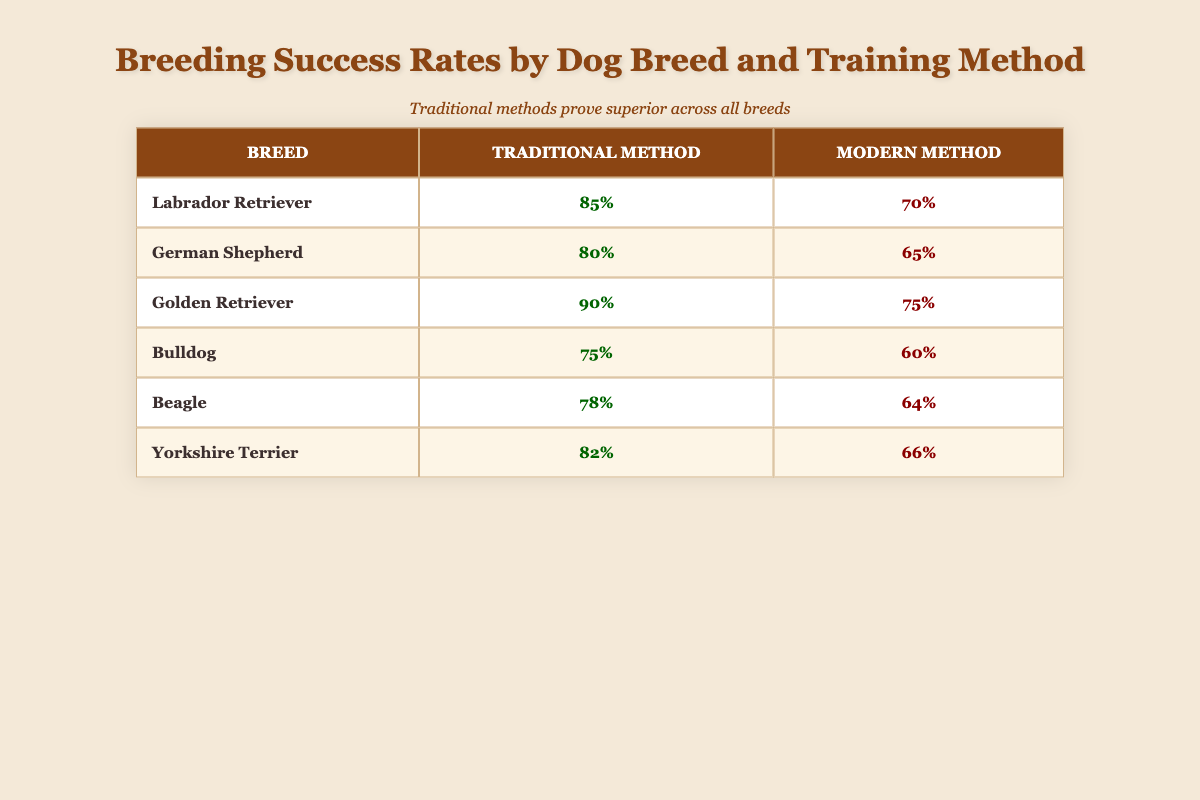What is the success rate for training Labrador Retrievers using traditional methods? The table shows that the success rate for training Labrador Retrievers with traditional methods is listed as 85%.
Answer: 85% Which training method results in a higher success rate for Beagles? In the table, the success rate for Beagles using traditional methods is 78%, while using modern methods it is 64%. Therefore, traditional methods yield a higher success rate.
Answer: Traditional methods What is the difference in success rate between the traditional and modern methods for German Shepherds? The success rate for German Shepherds with traditional methods is 80%, while the modern method has a success rate of 65%. The difference is calculated as 80% - 65% = 15%.
Answer: 15% Is the success rate for Golden Retrievers higher when using traditional methods compared to modern methods? According to the table, the success rate for Golden Retrievers with traditional methods is 90%, while the modern method's success rate is 75%. Since 90% is greater than 75%, the answer is yes.
Answer: Yes If we consider all breeds listed, what is the average success rate for traditional training methods? To calculate the average, we sum the success rates for traditional methods: 85% + 80% + 90% + 75% + 78% + 82% = 490%. There are 6 breeds, so we divide the total by 6: 490% / 6 = 81.67%.
Answer: 81.67% Which breed has the lowest success rate using modern training methods? The table reflects that Bulldogs have the lowest success rate with modern training methods at 60%, lower than that of the other breeds.
Answer: Bulldog Is there a breed that shows a success rate of exactly 75% using modern training methods? The table indicates that only the Golden Retriever and Bulldog exhibit success rates below and at 75%, but the Bulldog achieves a success rate of exactly 60% and does not meet or exceed 75%. Hence, the answer is no.
Answer: No What is the highest success rate achieved among all breeds using modern training methods? By examining the table, the highest success rate for modern training methods is for Golden Retrievers, at 75%. Other modern success rates are lower than that.
Answer: 75% 